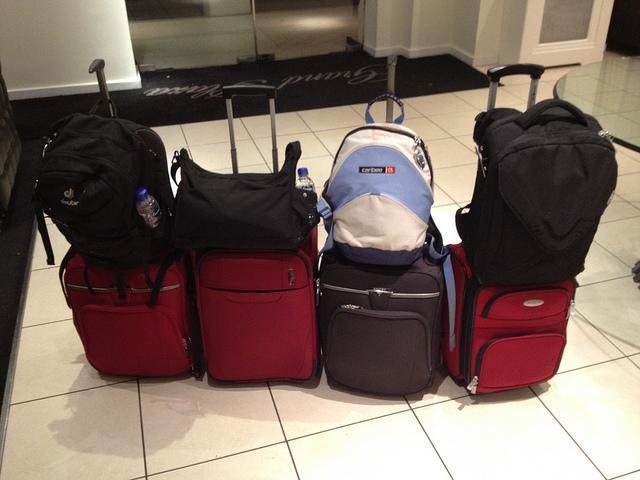How many red bags are in the picture?
Give a very brief answer. 3. How many suitcases can you see?
Give a very brief answer. 5. How many backpacks are visible?
Give a very brief answer. 3. 